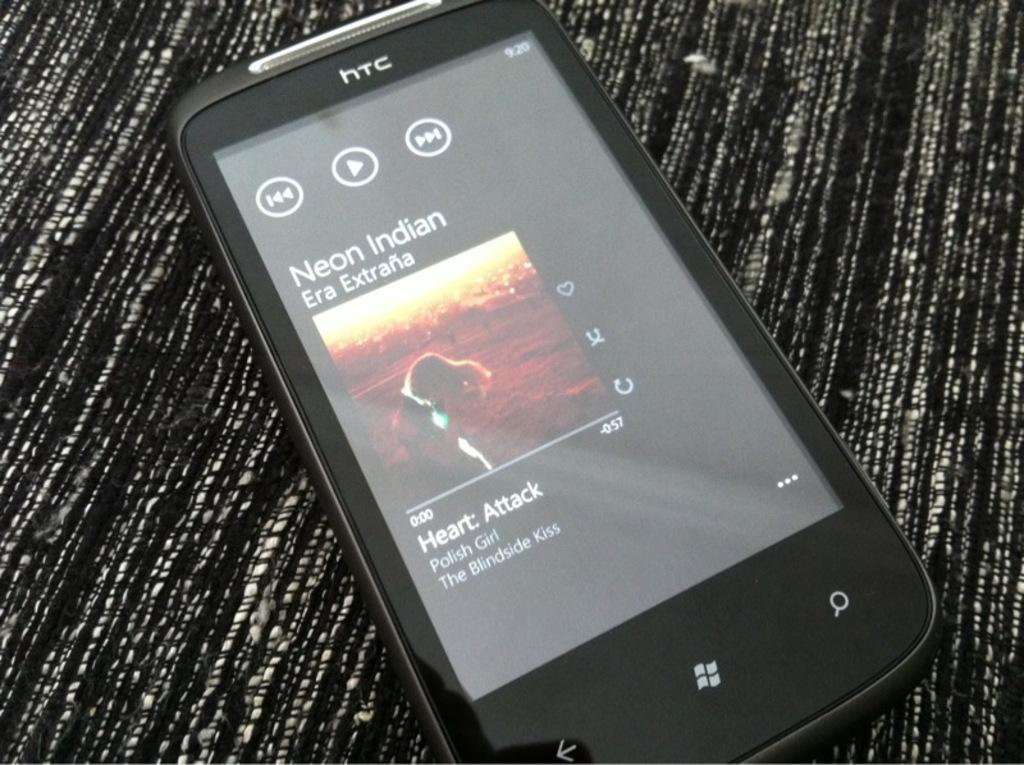<image>
Share a concise interpretation of the image provided. A phone plays a song by a group called Neon Indian. 